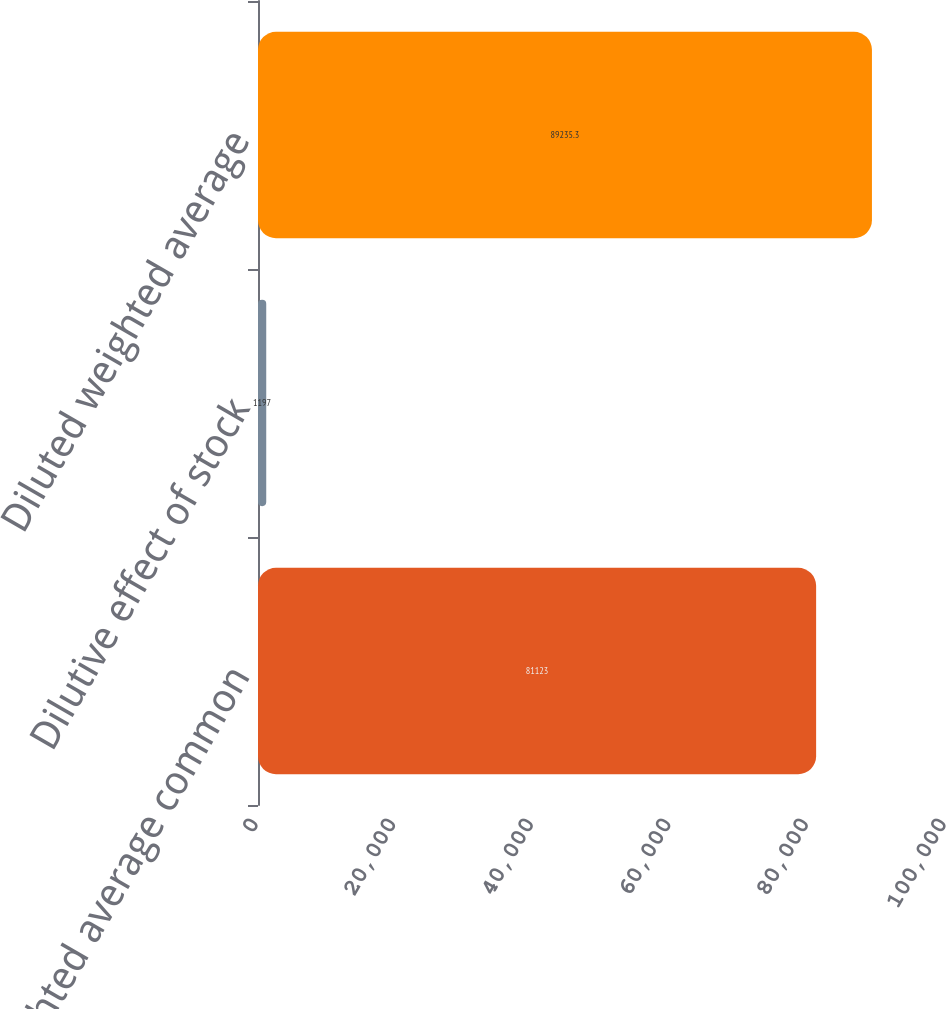<chart> <loc_0><loc_0><loc_500><loc_500><bar_chart><fcel>Basic weighted average common<fcel>Dilutive effect of stock<fcel>Diluted weighted average<nl><fcel>81123<fcel>1197<fcel>89235.3<nl></chart> 